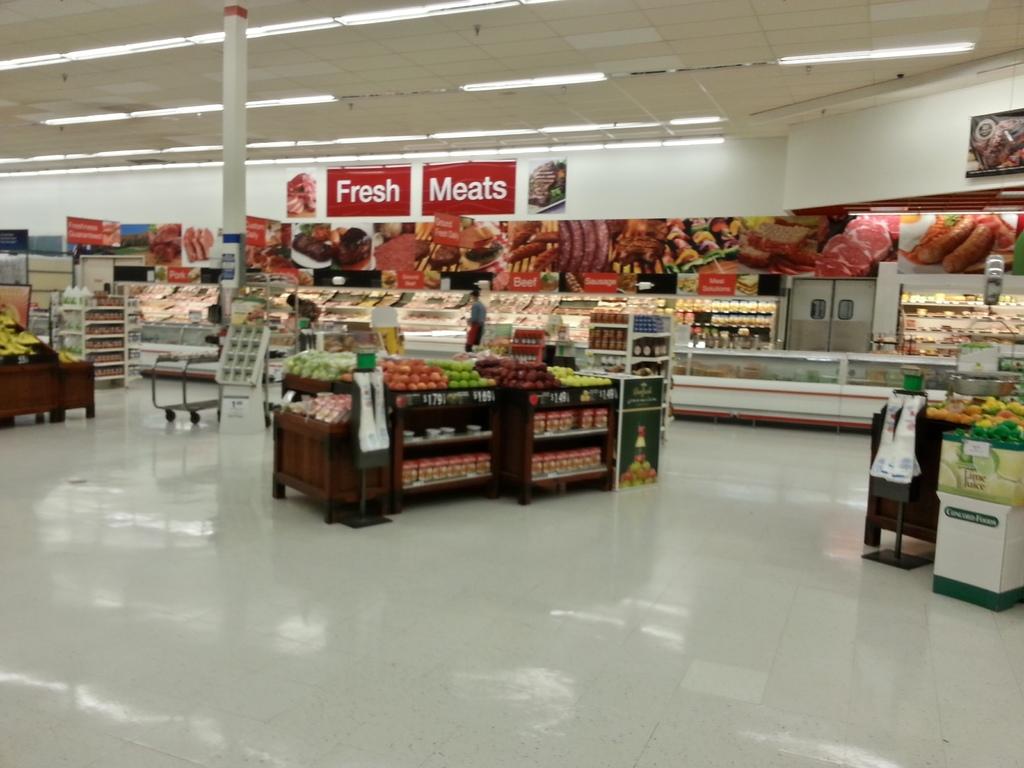What types of meats are advertised?
Keep it short and to the point. Fresh. Are the meats fresh according to the sign?
Keep it short and to the point. Yes. 